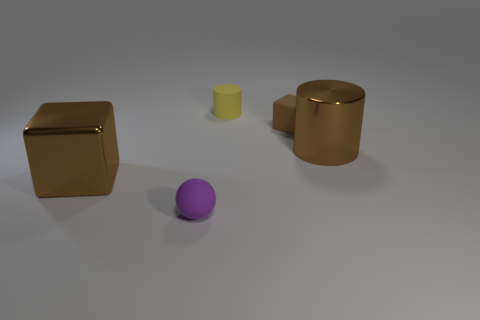How many big objects are cyan blocks or brown cubes?
Provide a short and direct response. 1. Is the number of small yellow cylinders that are on the right side of the tiny yellow matte cylinder less than the number of brown metallic cylinders behind the purple matte thing?
Provide a short and direct response. Yes. What number of things are either rubber spheres or tiny matte cylinders?
Provide a short and direct response. 2. There is a matte block; how many big brown metal cubes are right of it?
Ensure brevity in your answer.  0. Does the small matte sphere have the same color as the tiny rubber cube?
Your answer should be very brief. No. There is a tiny yellow object that is the same material as the small purple sphere; what shape is it?
Ensure brevity in your answer.  Cylinder. There is a brown metallic thing that is on the right side of the brown matte cube; is its shape the same as the purple thing?
Provide a succinct answer. No. How many purple things are cylinders or big metal objects?
Your answer should be compact. 0. Are there an equal number of cubes that are to the left of the small matte ball and yellow cylinders that are behind the small yellow matte object?
Ensure brevity in your answer.  No. There is a metal object behind the large brown metal thing on the left side of the tiny object that is in front of the tiny brown matte cube; what is its color?
Make the answer very short. Brown. 